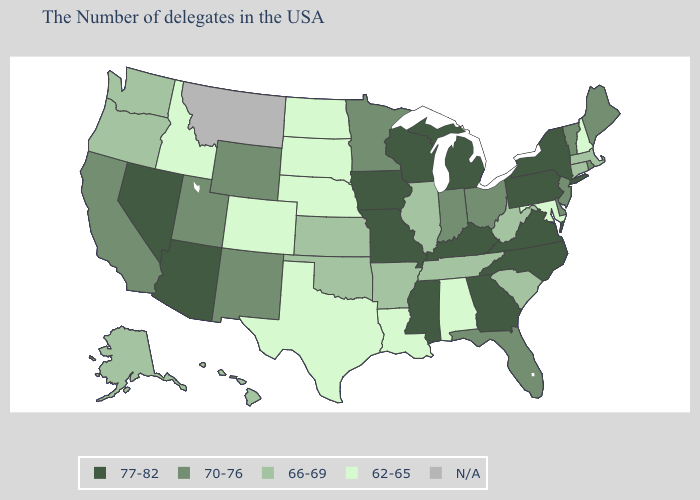What is the value of Missouri?
Concise answer only. 77-82. What is the lowest value in states that border Arkansas?
Concise answer only. 62-65. What is the highest value in the South ?
Short answer required. 77-82. What is the value of Texas?
Answer briefly. 62-65. Which states have the lowest value in the USA?
Quick response, please. New Hampshire, Maryland, Alabama, Louisiana, Nebraska, Texas, South Dakota, North Dakota, Colorado, Idaho. Does Nebraska have the lowest value in the USA?
Quick response, please. Yes. Does New Mexico have the lowest value in the USA?
Quick response, please. No. What is the highest value in the Northeast ?
Give a very brief answer. 77-82. Name the states that have a value in the range 62-65?
Be succinct. New Hampshire, Maryland, Alabama, Louisiana, Nebraska, Texas, South Dakota, North Dakota, Colorado, Idaho. Name the states that have a value in the range N/A?
Keep it brief. Montana. What is the value of Pennsylvania?
Be succinct. 77-82. 